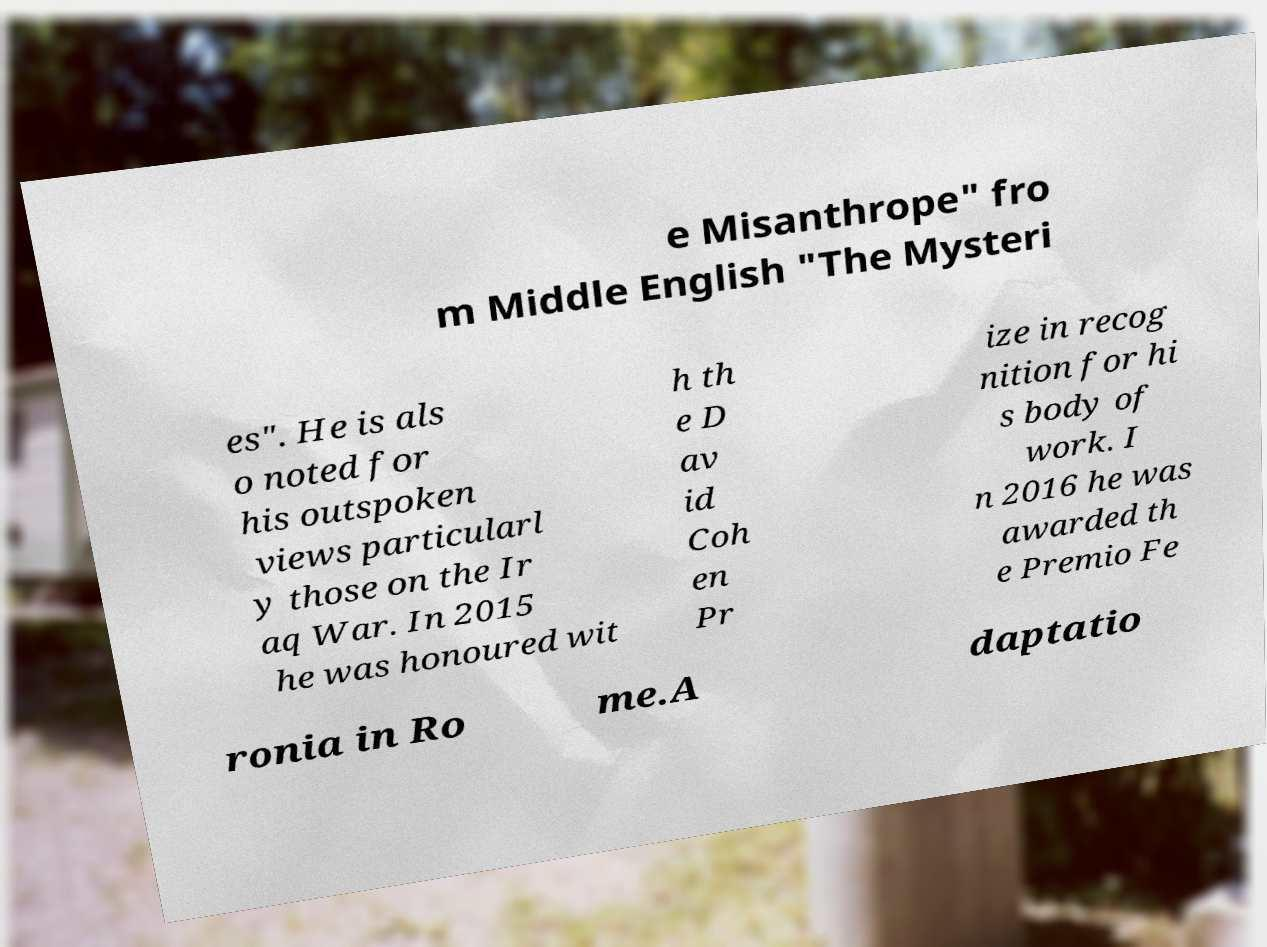Please identify and transcribe the text found in this image. e Misanthrope" fro m Middle English "The Mysteri es". He is als o noted for his outspoken views particularl y those on the Ir aq War. In 2015 he was honoured wit h th e D av id Coh en Pr ize in recog nition for hi s body of work. I n 2016 he was awarded th e Premio Fe ronia in Ro me.A daptatio 